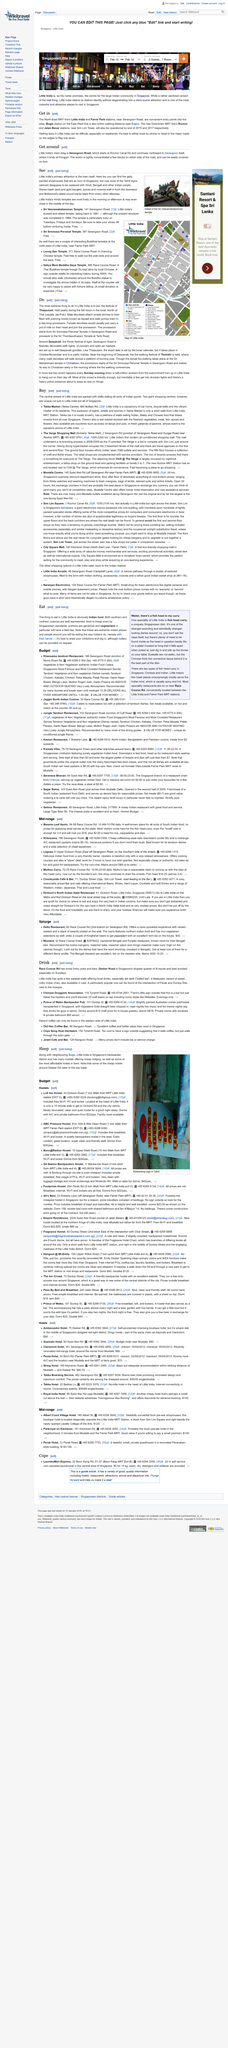Outline some significant characteristics in this image. The image depicts two lions. Yes, Singapore's Little India has Hindu temples that occasionally close in the middle of the day. Little India is renowned for its vibrant and colorful streets that are adorned with traditional Indian architecture and intricate decorations. As a result, the town itself is a primary attraction for tourists and locals alike, who come to explore the rich culture and history that it has to offer. 